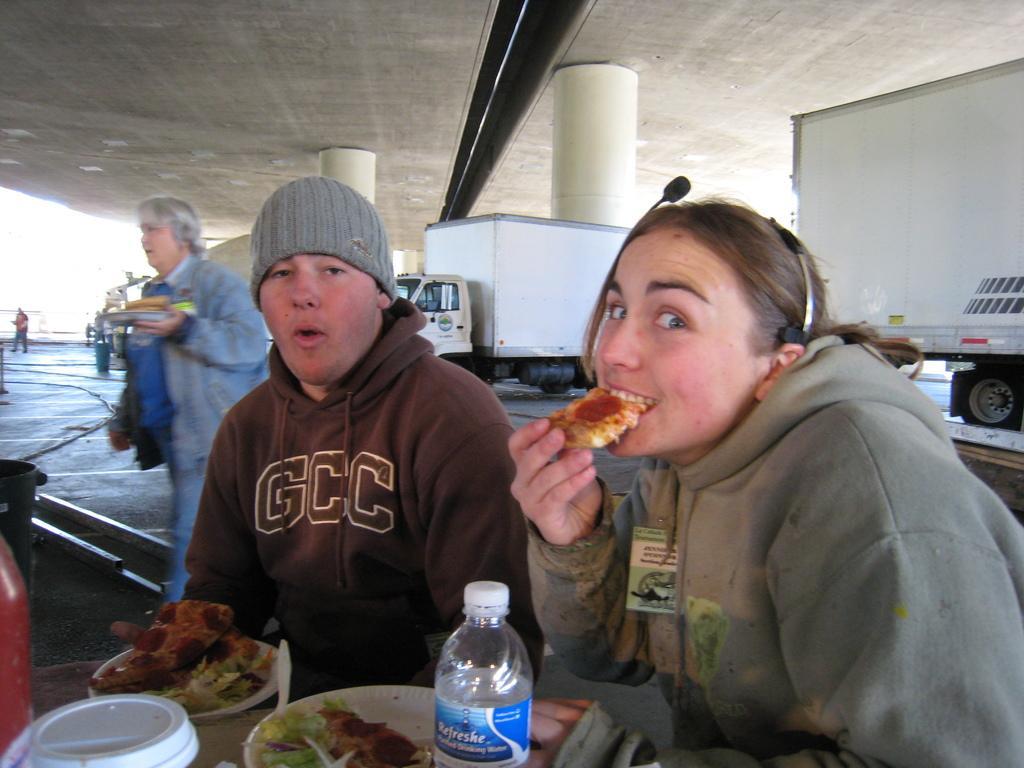Describe this image in one or two sentences. This is a picture outside the city. In the foreground there are two persons, on the right a woman is eating, on the center a person is seated. On the left there is a table, on the table there are two plates and water bottle and food. In the background there are trucks and pillars. On the left there is a woman and a person walking. 